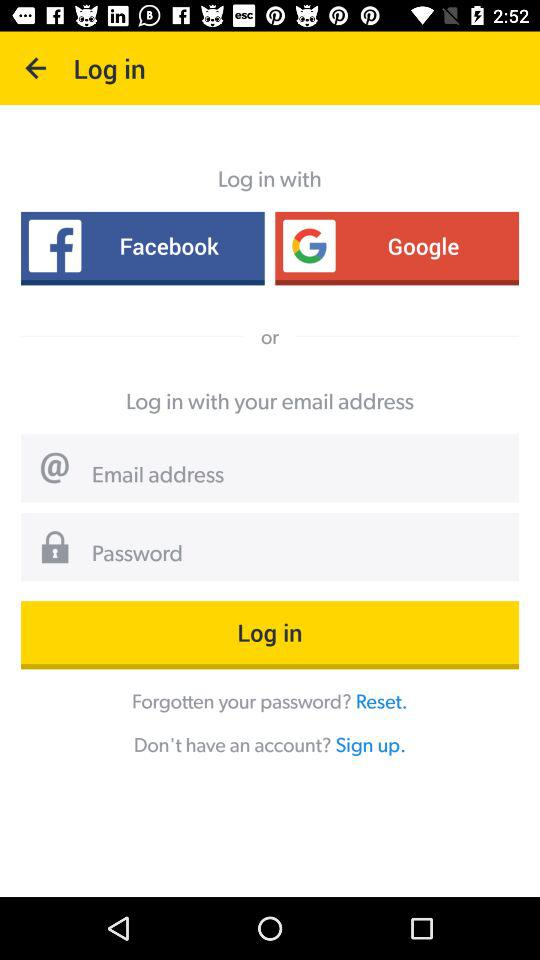Through what application can we login with? You can login with "Facebook", "Google" and "email address". 